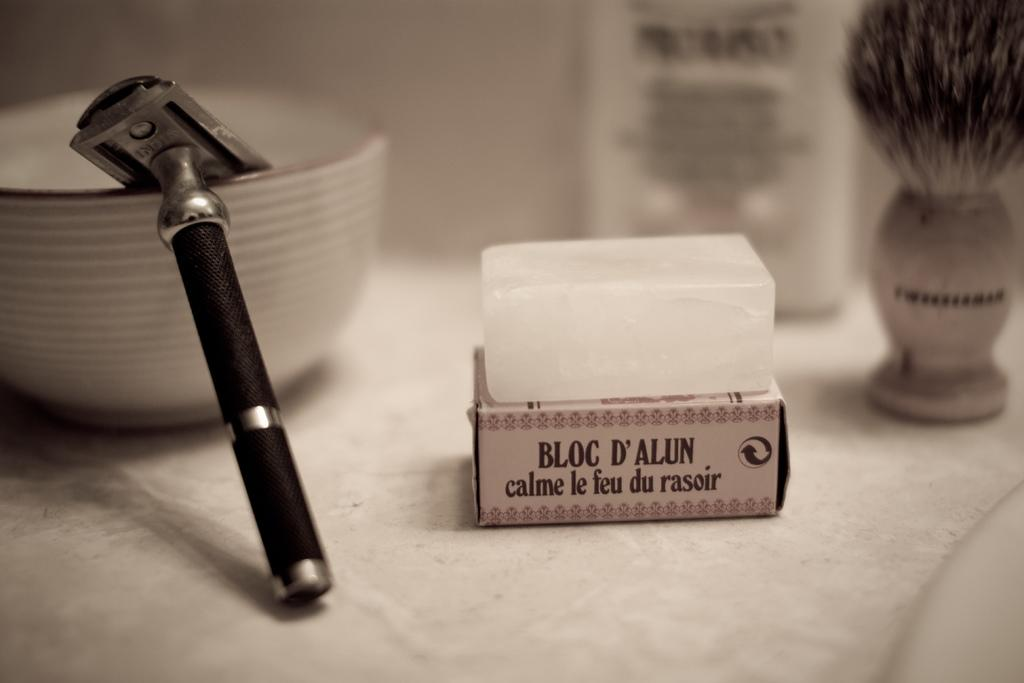Provide a one-sentence caption for the provided image. An old fashioned safety razor displayed with an Alum block and shaving brush. 